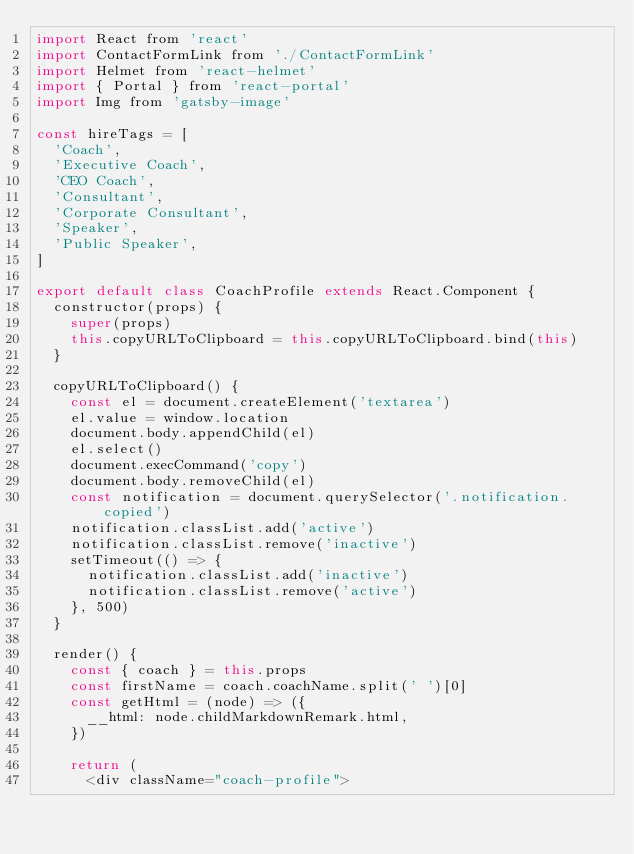<code> <loc_0><loc_0><loc_500><loc_500><_JavaScript_>import React from 'react'
import ContactFormLink from './ContactFormLink'
import Helmet from 'react-helmet'
import { Portal } from 'react-portal'
import Img from 'gatsby-image'

const hireTags = [
  'Coach',
  'Executive Coach',
  'CEO Coach',
  'Consultant',
  'Corporate Consultant',
  'Speaker',
  'Public Speaker',
]

export default class CoachProfile extends React.Component {
  constructor(props) {
    super(props)
    this.copyURLToClipboard = this.copyURLToClipboard.bind(this)
  }

  copyURLToClipboard() {
    const el = document.createElement('textarea')
    el.value = window.location
    document.body.appendChild(el)
    el.select()
    document.execCommand('copy')
    document.body.removeChild(el)
    const notification = document.querySelector('.notification.copied')
    notification.classList.add('active')
    notification.classList.remove('inactive')
    setTimeout(() => {
      notification.classList.add('inactive')
      notification.classList.remove('active')
    }, 500)
  }

  render() {
    const { coach } = this.props
    const firstName = coach.coachName.split(' ')[0]
    const getHtml = (node) => ({
      __html: node.childMarkdownRemark.html,
    })

    return (
      <div className="coach-profile"></code> 